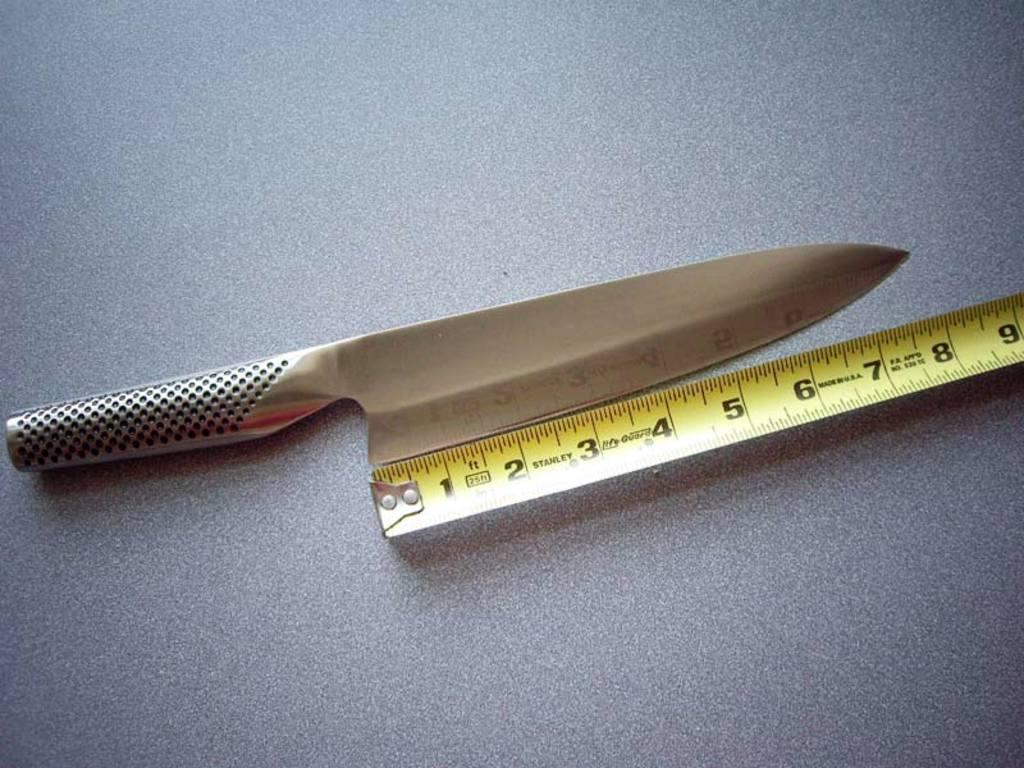Describe this image in one or two sentences. In this image we can see a knife and a measuring tape. 